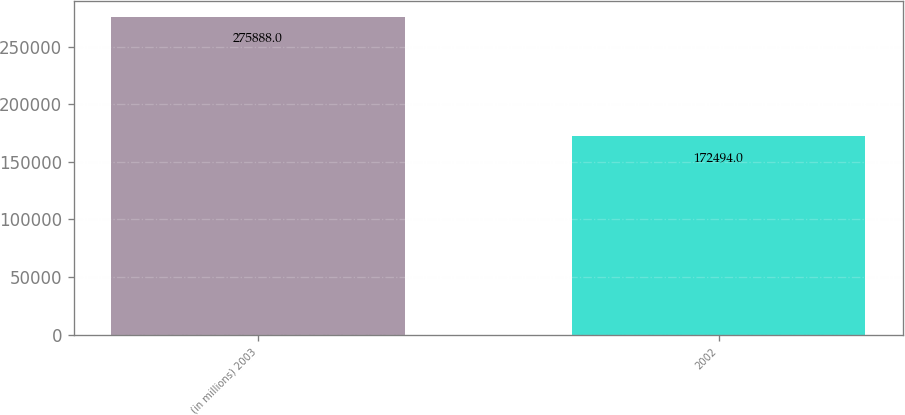Convert chart to OTSL. <chart><loc_0><loc_0><loc_500><loc_500><bar_chart><fcel>(in millions) 2003<fcel>2002<nl><fcel>275888<fcel>172494<nl></chart> 